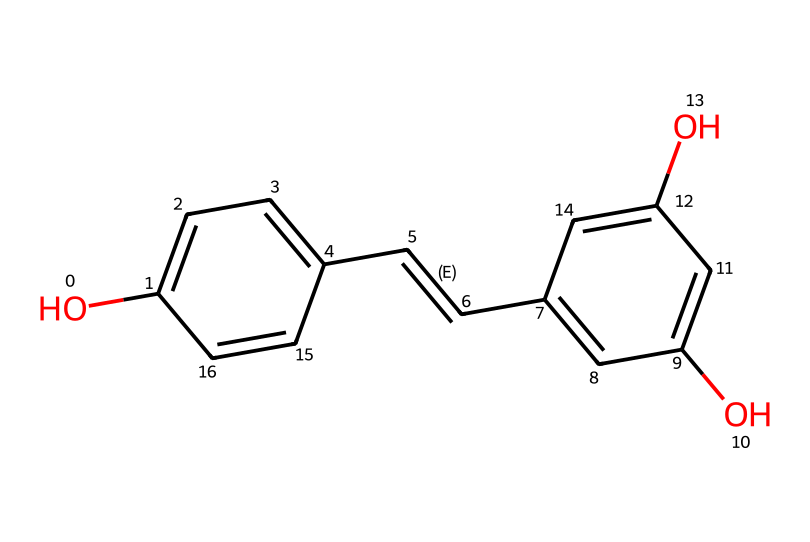What is the name of this antioxidant? The given SMILES representation corresponds to resveratrol, which is a well-known antioxidant found in red wine and grapes.
Answer: resveratrol How many hydroxyl (-OH) groups does this structure contain? Upon analyzing the structure, there are three hydroxyl (-OH) groups present, indicated by the 'O' atoms attached to benzene rings.
Answer: three What type of chemical functional groups are present in resveratrol? The chemical structure contains hydroxyl groups and a trans-alkene (C=C) double bond. The hydroxyl groups contribute to its antioxidant properties.
Answer: hydroxyl groups and trans-alkene What is the total number of carbon (C) atoms in resveratrol? By counting the carbon atoms in the structure, we find there are 14 carbon atoms in total.
Answer: 14 Does resveratrol possess any double bonds, and if so, how many? Yes, there is one double bond present in the structure, indicated by the "/C=C/" notation in the SMILES representation.
Answer: one How does the chemical structure of resveratrol contribute to its antioxidant properties? The presence of multiple hydroxyl groups in the structure gives resveratrol its ability to donate electrons, thereby neutralizing free radicals and preventing oxidative stress.
Answer: hydroxyl groups 